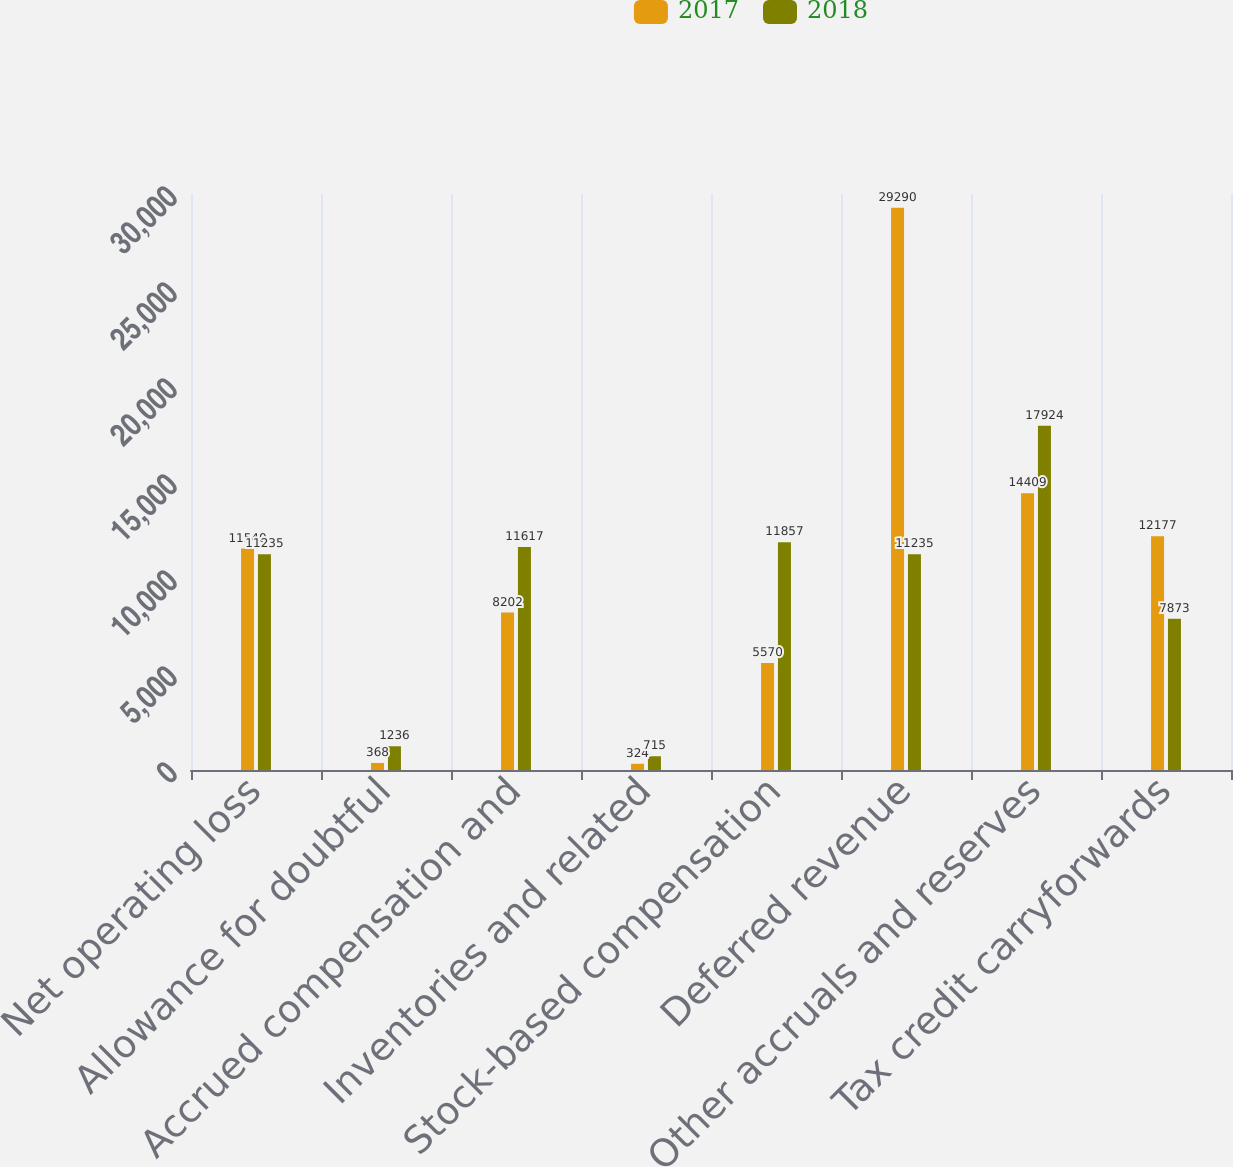Convert chart. <chart><loc_0><loc_0><loc_500><loc_500><stacked_bar_chart><ecel><fcel>Net operating loss<fcel>Allowance for doubtful<fcel>Accrued compensation and<fcel>Inventories and related<fcel>Stock-based compensation<fcel>Deferred revenue<fcel>Other accruals and reserves<fcel>Tax credit carryforwards<nl><fcel>2017<fcel>11540<fcel>368<fcel>8202<fcel>324<fcel>5570<fcel>29290<fcel>14409<fcel>12177<nl><fcel>2018<fcel>11235<fcel>1236<fcel>11617<fcel>715<fcel>11857<fcel>11235<fcel>17924<fcel>7873<nl></chart> 